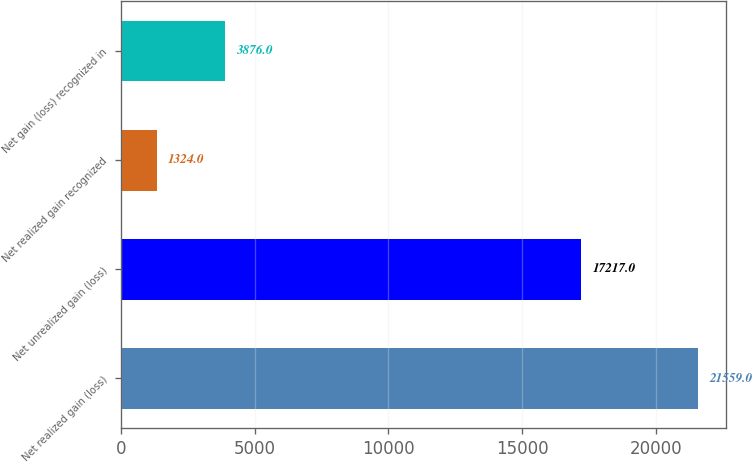<chart> <loc_0><loc_0><loc_500><loc_500><bar_chart><fcel>Net realized gain (loss)<fcel>Net unrealized gain (loss)<fcel>Net realized gain recognized<fcel>Net gain (loss) recognized in<nl><fcel>21559<fcel>17217<fcel>1324<fcel>3876<nl></chart> 